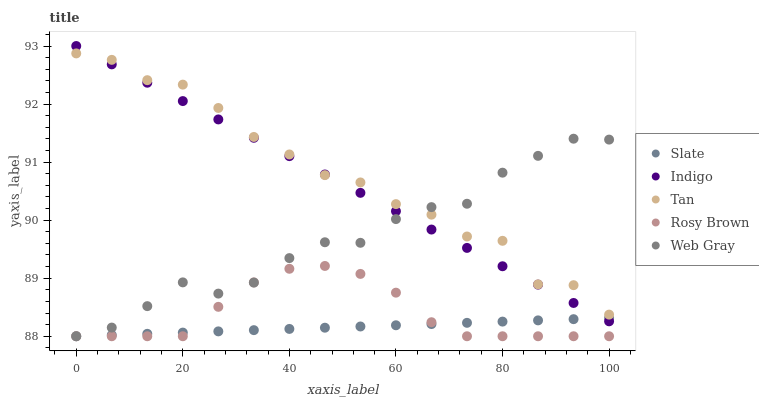Does Slate have the minimum area under the curve?
Answer yes or no. Yes. Does Tan have the maximum area under the curve?
Answer yes or no. Yes. Does Rosy Brown have the minimum area under the curve?
Answer yes or no. No. Does Rosy Brown have the maximum area under the curve?
Answer yes or no. No. Is Slate the smoothest?
Answer yes or no. Yes. Is Tan the roughest?
Answer yes or no. Yes. Is Rosy Brown the smoothest?
Answer yes or no. No. Is Rosy Brown the roughest?
Answer yes or no. No. Does Web Gray have the lowest value?
Answer yes or no. Yes. Does Indigo have the lowest value?
Answer yes or no. No. Does Indigo have the highest value?
Answer yes or no. Yes. Does Rosy Brown have the highest value?
Answer yes or no. No. Is Rosy Brown less than Tan?
Answer yes or no. Yes. Is Tan greater than Rosy Brown?
Answer yes or no. Yes. Does Web Gray intersect Indigo?
Answer yes or no. Yes. Is Web Gray less than Indigo?
Answer yes or no. No. Is Web Gray greater than Indigo?
Answer yes or no. No. Does Rosy Brown intersect Tan?
Answer yes or no. No. 